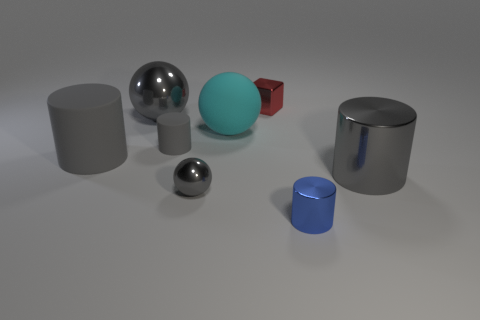Subtract all gray cylinders. How many were subtracted if there are1gray cylinders left? 2 Subtract all blue balls. How many gray cylinders are left? 3 Subtract all gray cylinders. How many cylinders are left? 1 Add 1 shiny cylinders. How many objects exist? 9 Subtract all brown cylinders. Subtract all green cubes. How many cylinders are left? 4 Subtract all cubes. How many objects are left? 7 Add 2 tiny metallic balls. How many tiny metallic balls are left? 3 Add 4 large yellow rubber cylinders. How many large yellow rubber cylinders exist? 4 Subtract 0 green blocks. How many objects are left? 8 Subtract all small things. Subtract all cyan rubber cylinders. How many objects are left? 4 